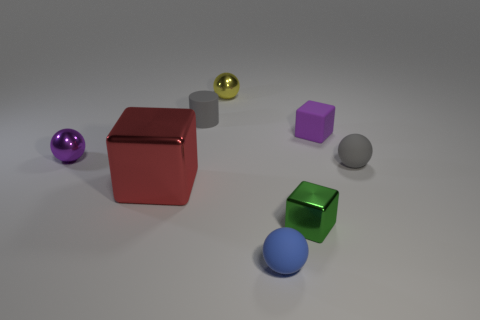Is there a tiny sphere that has the same color as the matte cylinder?
Ensure brevity in your answer.  Yes. There is a purple cube that is the same material as the tiny cylinder; what size is it?
Ensure brevity in your answer.  Small. What shape is the small gray rubber thing that is left of the tiny cube left of the tiny rubber block behind the tiny blue matte ball?
Offer a terse response. Cylinder. What is the size of the other metallic thing that is the same shape as the purple metal thing?
Offer a very short reply. Small. There is a rubber thing that is both in front of the purple rubber thing and to the left of the small purple block; what size is it?
Keep it short and to the point. Small. The object that is the same color as the rubber block is what shape?
Your answer should be compact. Sphere. What is the color of the large cube?
Your answer should be very brief. Red. What size is the gray object behind the purple matte block?
Keep it short and to the point. Small. How many tiny yellow objects are right of the metal thing in front of the red metallic block to the left of the tiny cylinder?
Provide a succinct answer. 0. The matte thing that is in front of the gray matte thing that is to the right of the green metallic thing is what color?
Provide a short and direct response. Blue. 